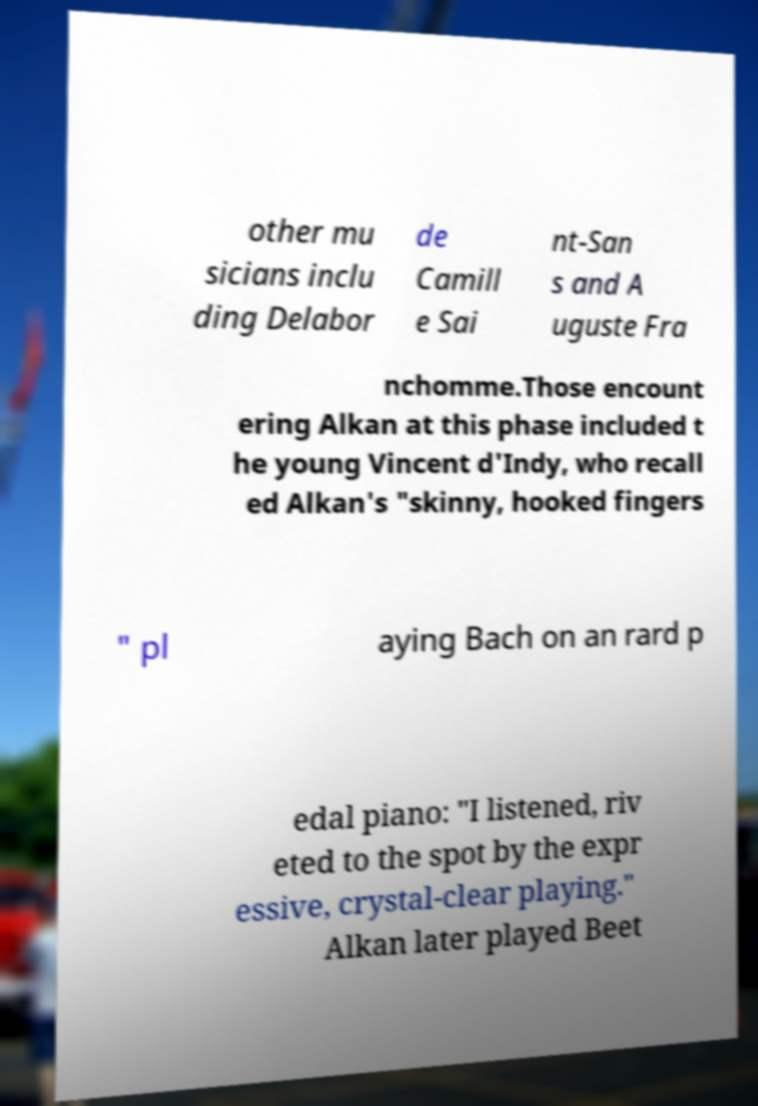Please identify and transcribe the text found in this image. other mu sicians inclu ding Delabor de Camill e Sai nt-San s and A uguste Fra nchomme.Those encount ering Alkan at this phase included t he young Vincent d'Indy, who recall ed Alkan's "skinny, hooked fingers " pl aying Bach on an rard p edal piano: "I listened, riv eted to the spot by the expr essive, crystal-clear playing." Alkan later played Beet 